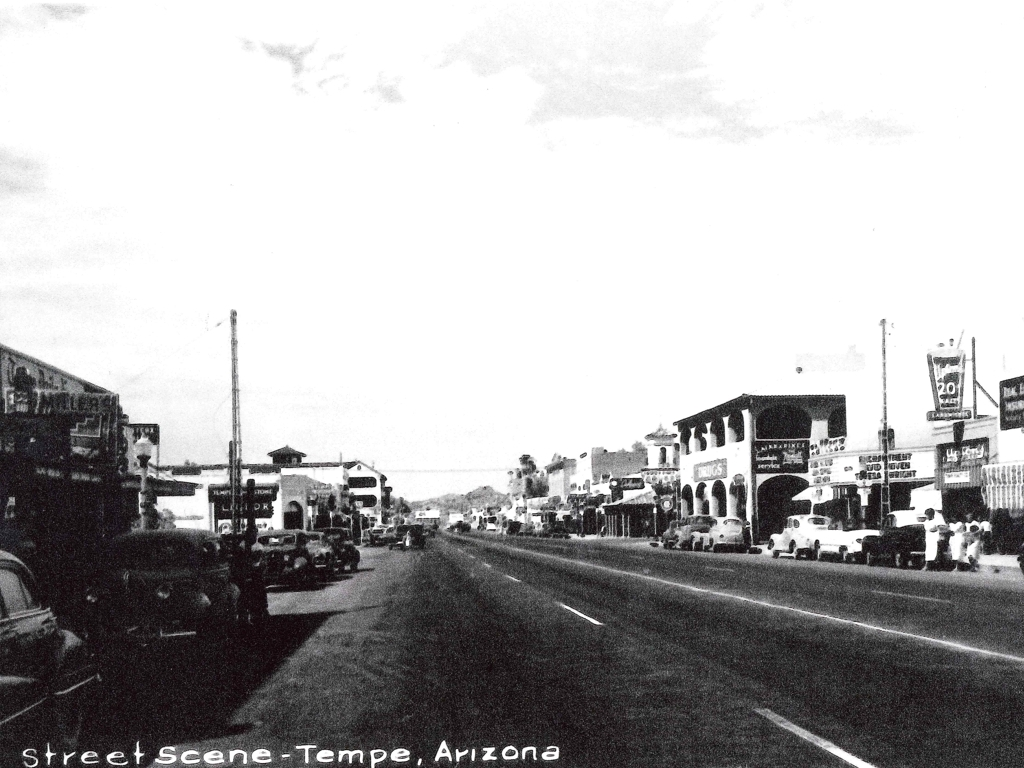Why is the clarity of this photo not very high? The photo appears to be impacted by a few factors contributing to its suboptimal clarity: there's visible noise, indicative of either a high ISO setting used during a low-light situation or the degradation that comes with age and reproduction of an old photograph. Additionally, the contrast seems quite high, which can diminish finer details. Improved lighting conditions and a lower ISO setting might have resulted in a clearer image. 